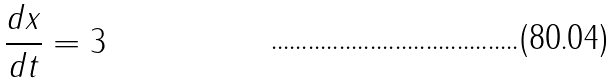<formula> <loc_0><loc_0><loc_500><loc_500>\frac { d x } { d t } = 3</formula> 